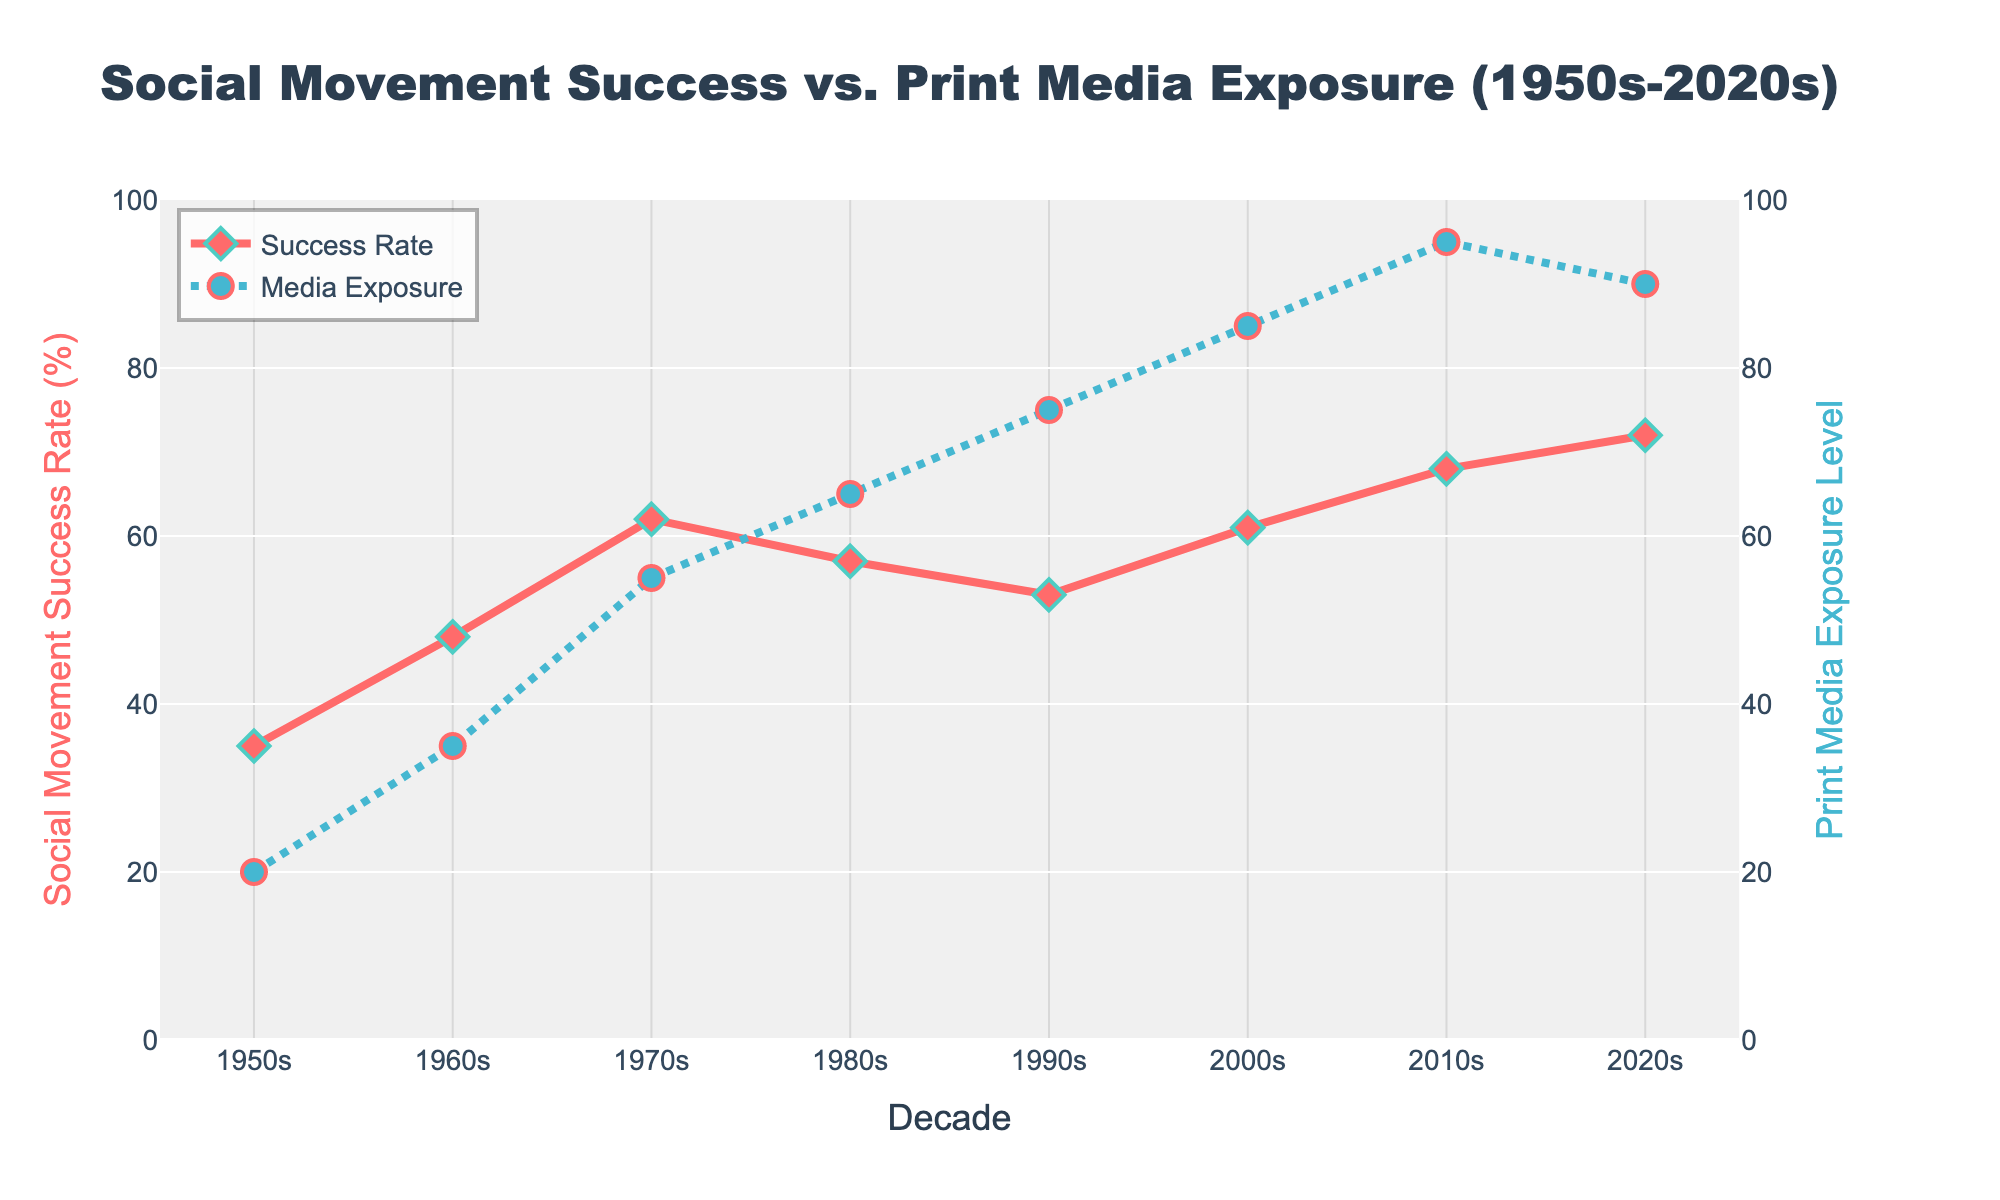What is the social movement success rate in the 2010s? Refer to the y-axis labeled "Social Movement Success Rate (%)" and find the data point for the 2010s. It is 68%.
Answer: 68% What is the difference in media exposure levels between the 1960s and the 2000s? Look at the y-axis labeled "Print Media Exposure Level" and locate the values for the 1960s (35) and 2000s (85). Subtract the smaller value from the larger one: 85 - 35 = 50.
Answer: 50 Which decade had the highest social movement success rate? Refer to the line of "Social Movement Success Rate" and find the highest data point. It occurs in the 2020s, with a value of 72%.
Answer: 2020s Compare the media exposure level in the 1990s to the social movement success rate in the same decade. Which one is higher? Identify the values for both metrics in the 1990s: Media Exposure Level is 75, and Social Movement Success Rate is 53. The media exposure level is higher.
Answer: Media Exposure Level What is the average social movement success rate over the seven decades? Sum up the social movement success rates from each decade: (35 + 48 + 62 + 57 + 53 + 61 + 68 + 72) = 456. Then divide by 8 (the total number of decades): 456 / 8 = 57.
Answer: 57 Between which decades is the increase in print media exposure levels the greatest? Calculate the differences in print media exposure levels between consecutive decades. The greatest increase is between the 1950s (20) and the 1960s (35), with a difference of 35 - 20 = 15, which is not the highest. The highest difference is between the 2000s (85) and 2010s (95), a difference of 10. Thus the difference between 2000s and 2010s.
Answer: 2000s to 2010s What is the rate of change in social movement success from the 1980s to the 1990s? Subtract the value of the 1980s (57) from that of the 1990s (53): 53 - 57 = -4. The rate of change is -4.
Answer: -4 What color represents the social movement success rate? The visual line representing the social movement success rate is colored red.
Answer: red Is there a decade where the media exposure level decreased compared to the previous decade? Compare media exposure levels across decades. From the 2010s (95) to the 2020s (90), there is a decrease.
Answer: Yes By how much did the social movement success rate increase from the 1950s to the 2020s? Identify social movement success rates for the 1950s (35) and 2020s (72). Subtract the older value from the more recent one: 72 - 35 = 37.
Answer: 37 